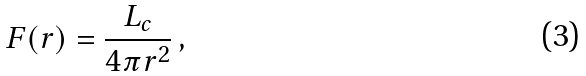Convert formula to latex. <formula><loc_0><loc_0><loc_500><loc_500>F ( r ) = \frac { L _ { c } } { 4 \pi r ^ { 2 } } \, ,</formula> 